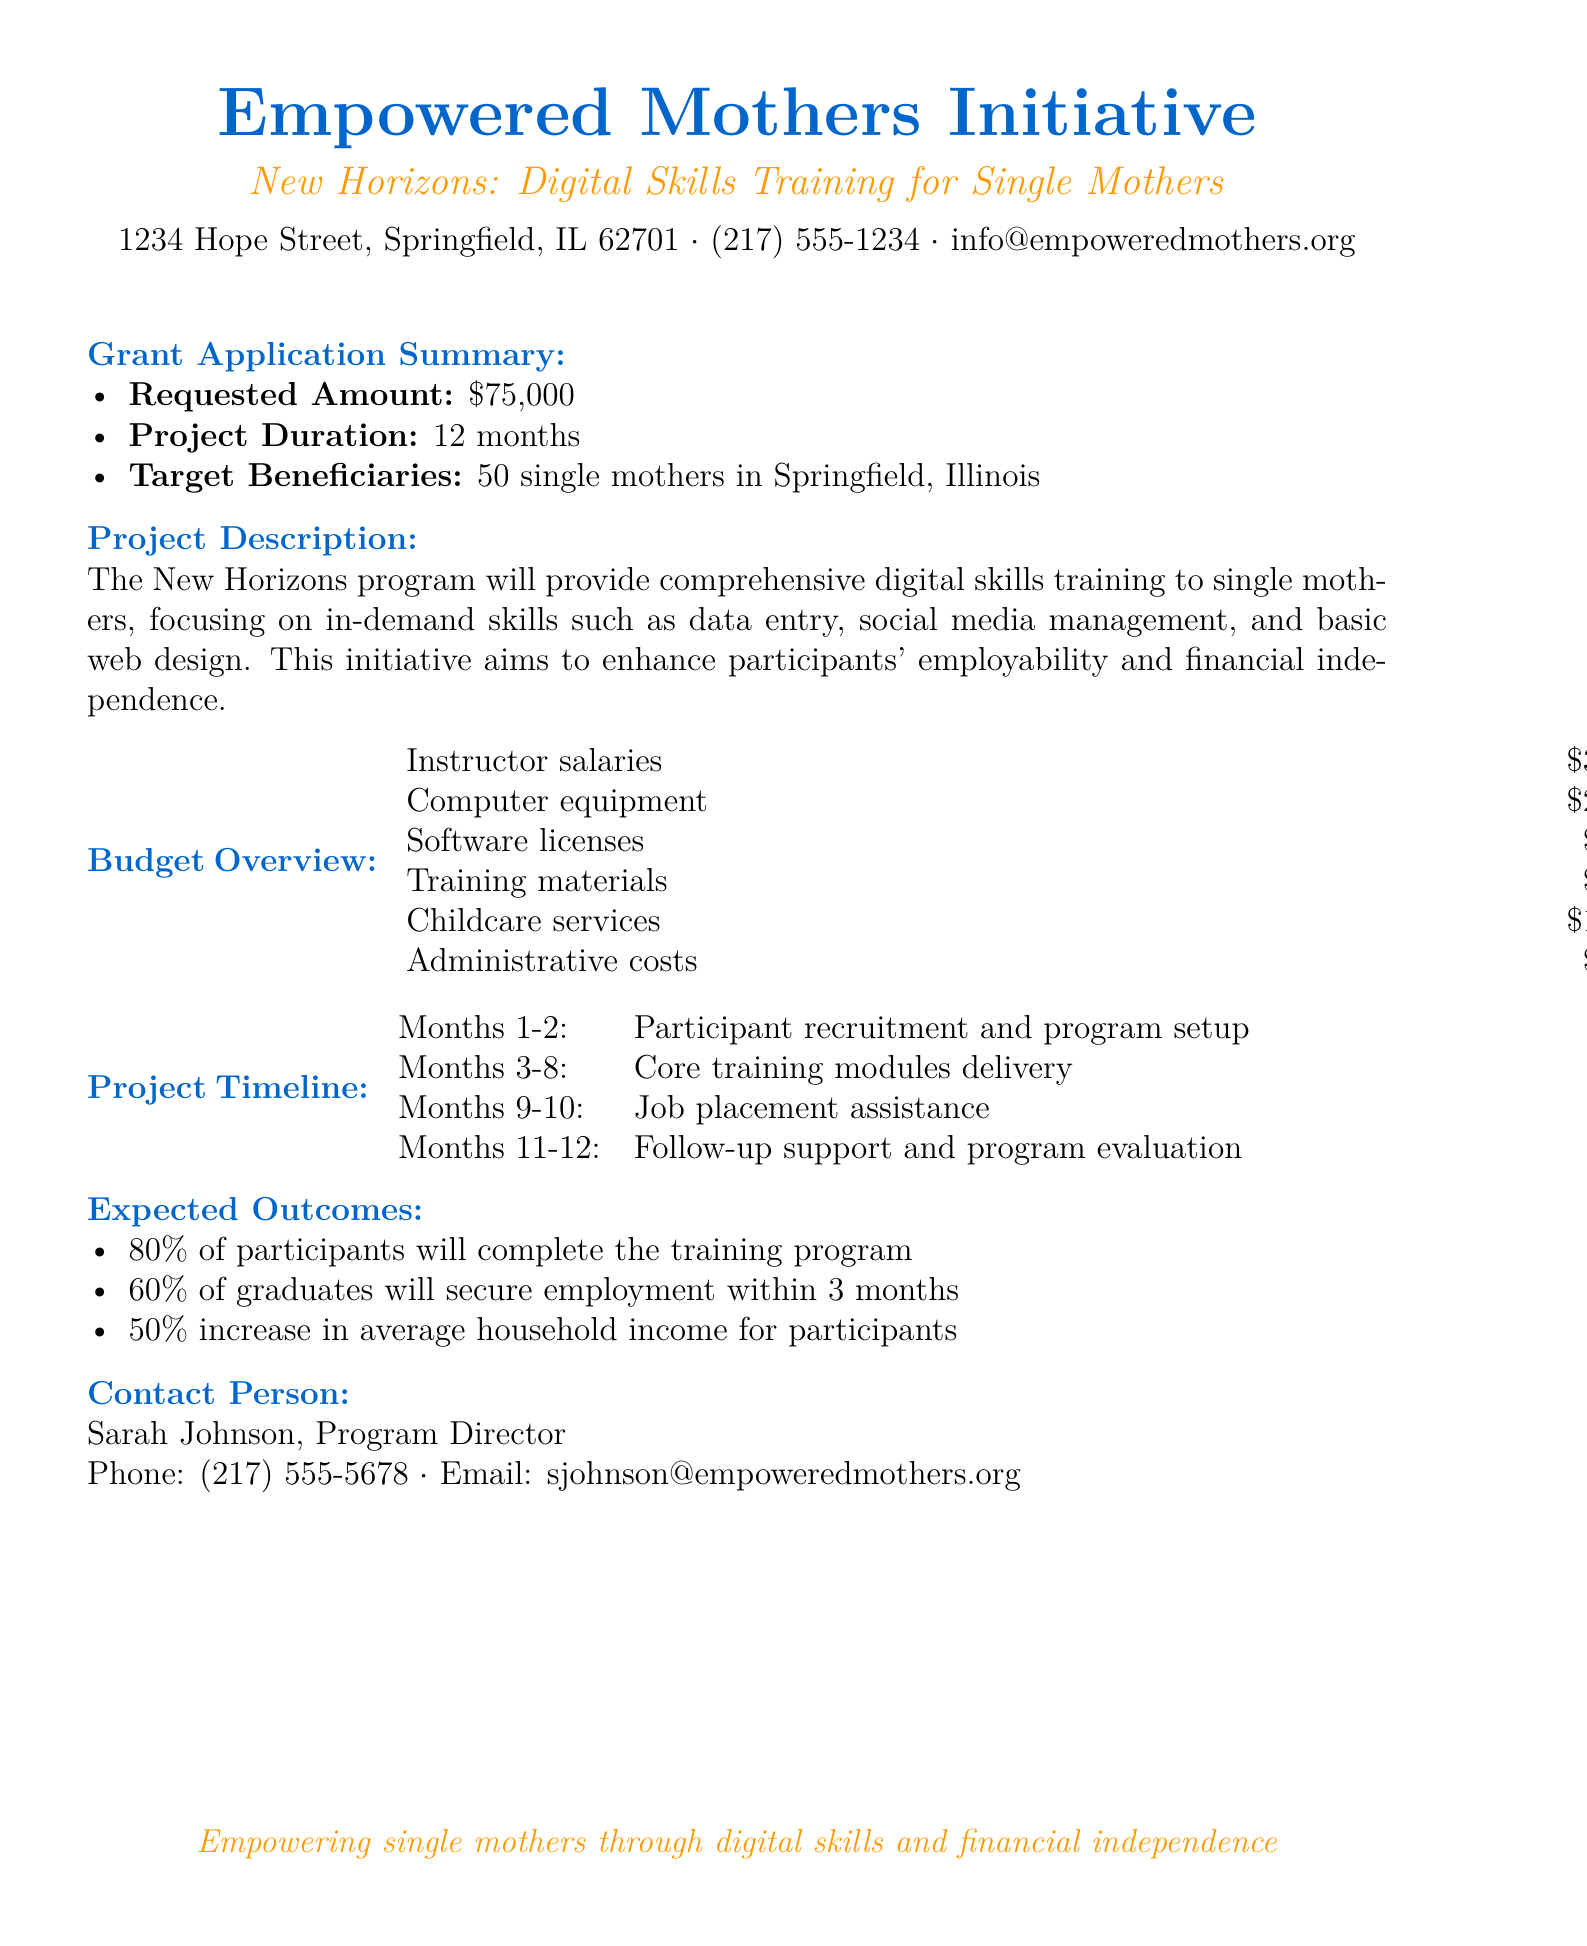What is the requested amount for the grant? The requested amount is specified in the document as \$75,000.
Answer: \$75,000 How long is the project duration? The project duration is outlined in the document as 12 months.
Answer: 12 months Who is the target beneficiary group for the program? The target beneficiaries listed in the document are single mothers in Springfield, Illinois.
Answer: 50 single mothers What are the training areas covered in the program? The document lists digital skills such as data entry, social media management, and basic web design as training areas.
Answer: Digital skills training What percentage of participants is expected to complete the training program? The expected outcomes section states that 80% of participants will complete the training program.
Answer: 80% What is the budget for childcare services? The budget overview specifies that the cost for childcare services is \$12,000.
Answer: \$12,000 During which months will job placement assistance be provided? The project timeline indicates job placement assistance will occur in months 9-10.
Answer: Months 9-10 Who is the contact person for the program? The document identifies Sarah Johnson as the contact person.
Answer: Sarah Johnson What is the email address for the program director? The contact information section includes the email sjohnson@empoweredmothers.org for Sarah Johnson.
Answer: sjohnson@empoweredmothers.org 